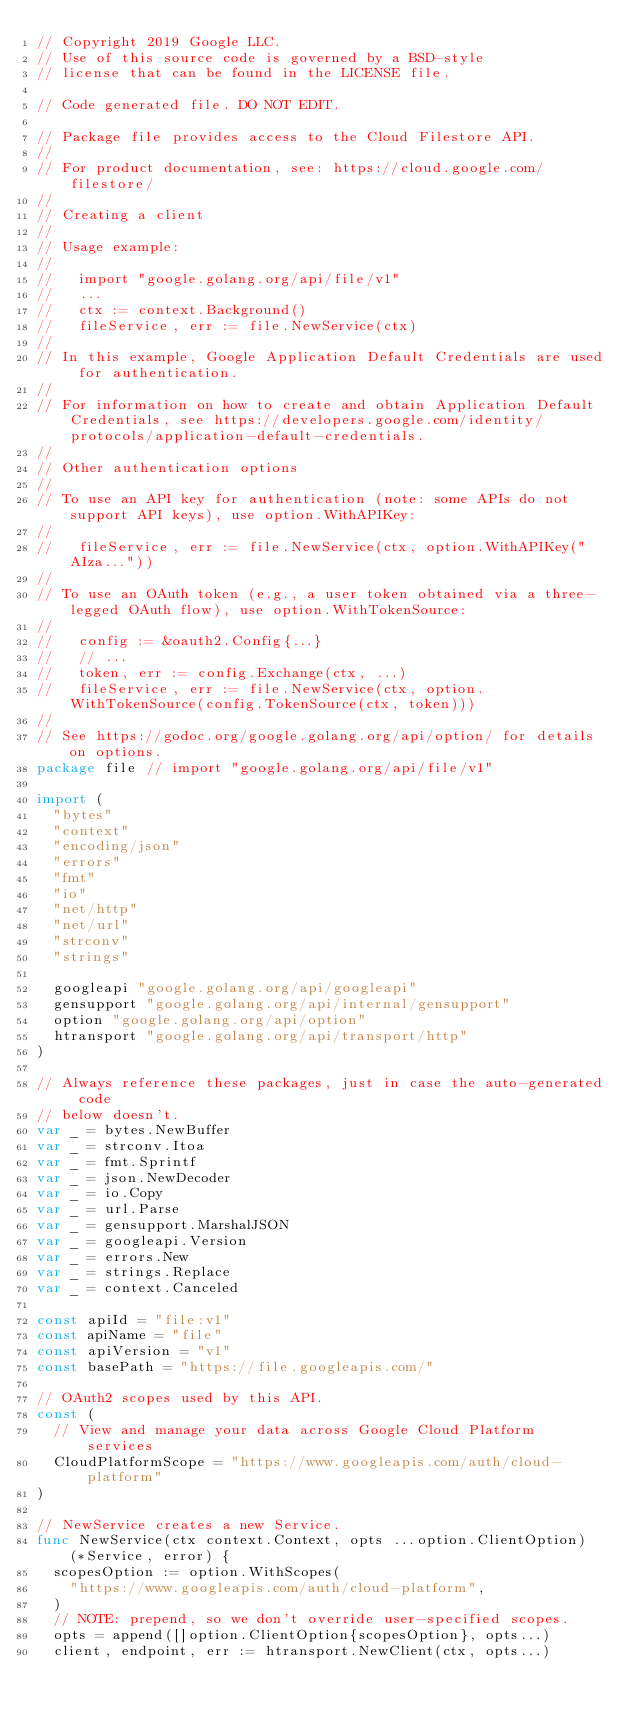Convert code to text. <code><loc_0><loc_0><loc_500><loc_500><_Go_>// Copyright 2019 Google LLC.
// Use of this source code is governed by a BSD-style
// license that can be found in the LICENSE file.

// Code generated file. DO NOT EDIT.

// Package file provides access to the Cloud Filestore API.
//
// For product documentation, see: https://cloud.google.com/filestore/
//
// Creating a client
//
// Usage example:
//
//   import "google.golang.org/api/file/v1"
//   ...
//   ctx := context.Background()
//   fileService, err := file.NewService(ctx)
//
// In this example, Google Application Default Credentials are used for authentication.
//
// For information on how to create and obtain Application Default Credentials, see https://developers.google.com/identity/protocols/application-default-credentials.
//
// Other authentication options
//
// To use an API key for authentication (note: some APIs do not support API keys), use option.WithAPIKey:
//
//   fileService, err := file.NewService(ctx, option.WithAPIKey("AIza..."))
//
// To use an OAuth token (e.g., a user token obtained via a three-legged OAuth flow), use option.WithTokenSource:
//
//   config := &oauth2.Config{...}
//   // ...
//   token, err := config.Exchange(ctx, ...)
//   fileService, err := file.NewService(ctx, option.WithTokenSource(config.TokenSource(ctx, token)))
//
// See https://godoc.org/google.golang.org/api/option/ for details on options.
package file // import "google.golang.org/api/file/v1"

import (
	"bytes"
	"context"
	"encoding/json"
	"errors"
	"fmt"
	"io"
	"net/http"
	"net/url"
	"strconv"
	"strings"

	googleapi "google.golang.org/api/googleapi"
	gensupport "google.golang.org/api/internal/gensupport"
	option "google.golang.org/api/option"
	htransport "google.golang.org/api/transport/http"
)

// Always reference these packages, just in case the auto-generated code
// below doesn't.
var _ = bytes.NewBuffer
var _ = strconv.Itoa
var _ = fmt.Sprintf
var _ = json.NewDecoder
var _ = io.Copy
var _ = url.Parse
var _ = gensupport.MarshalJSON
var _ = googleapi.Version
var _ = errors.New
var _ = strings.Replace
var _ = context.Canceled

const apiId = "file:v1"
const apiName = "file"
const apiVersion = "v1"
const basePath = "https://file.googleapis.com/"

// OAuth2 scopes used by this API.
const (
	// View and manage your data across Google Cloud Platform services
	CloudPlatformScope = "https://www.googleapis.com/auth/cloud-platform"
)

// NewService creates a new Service.
func NewService(ctx context.Context, opts ...option.ClientOption) (*Service, error) {
	scopesOption := option.WithScopes(
		"https://www.googleapis.com/auth/cloud-platform",
	)
	// NOTE: prepend, so we don't override user-specified scopes.
	opts = append([]option.ClientOption{scopesOption}, opts...)
	client, endpoint, err := htransport.NewClient(ctx, opts...)</code> 